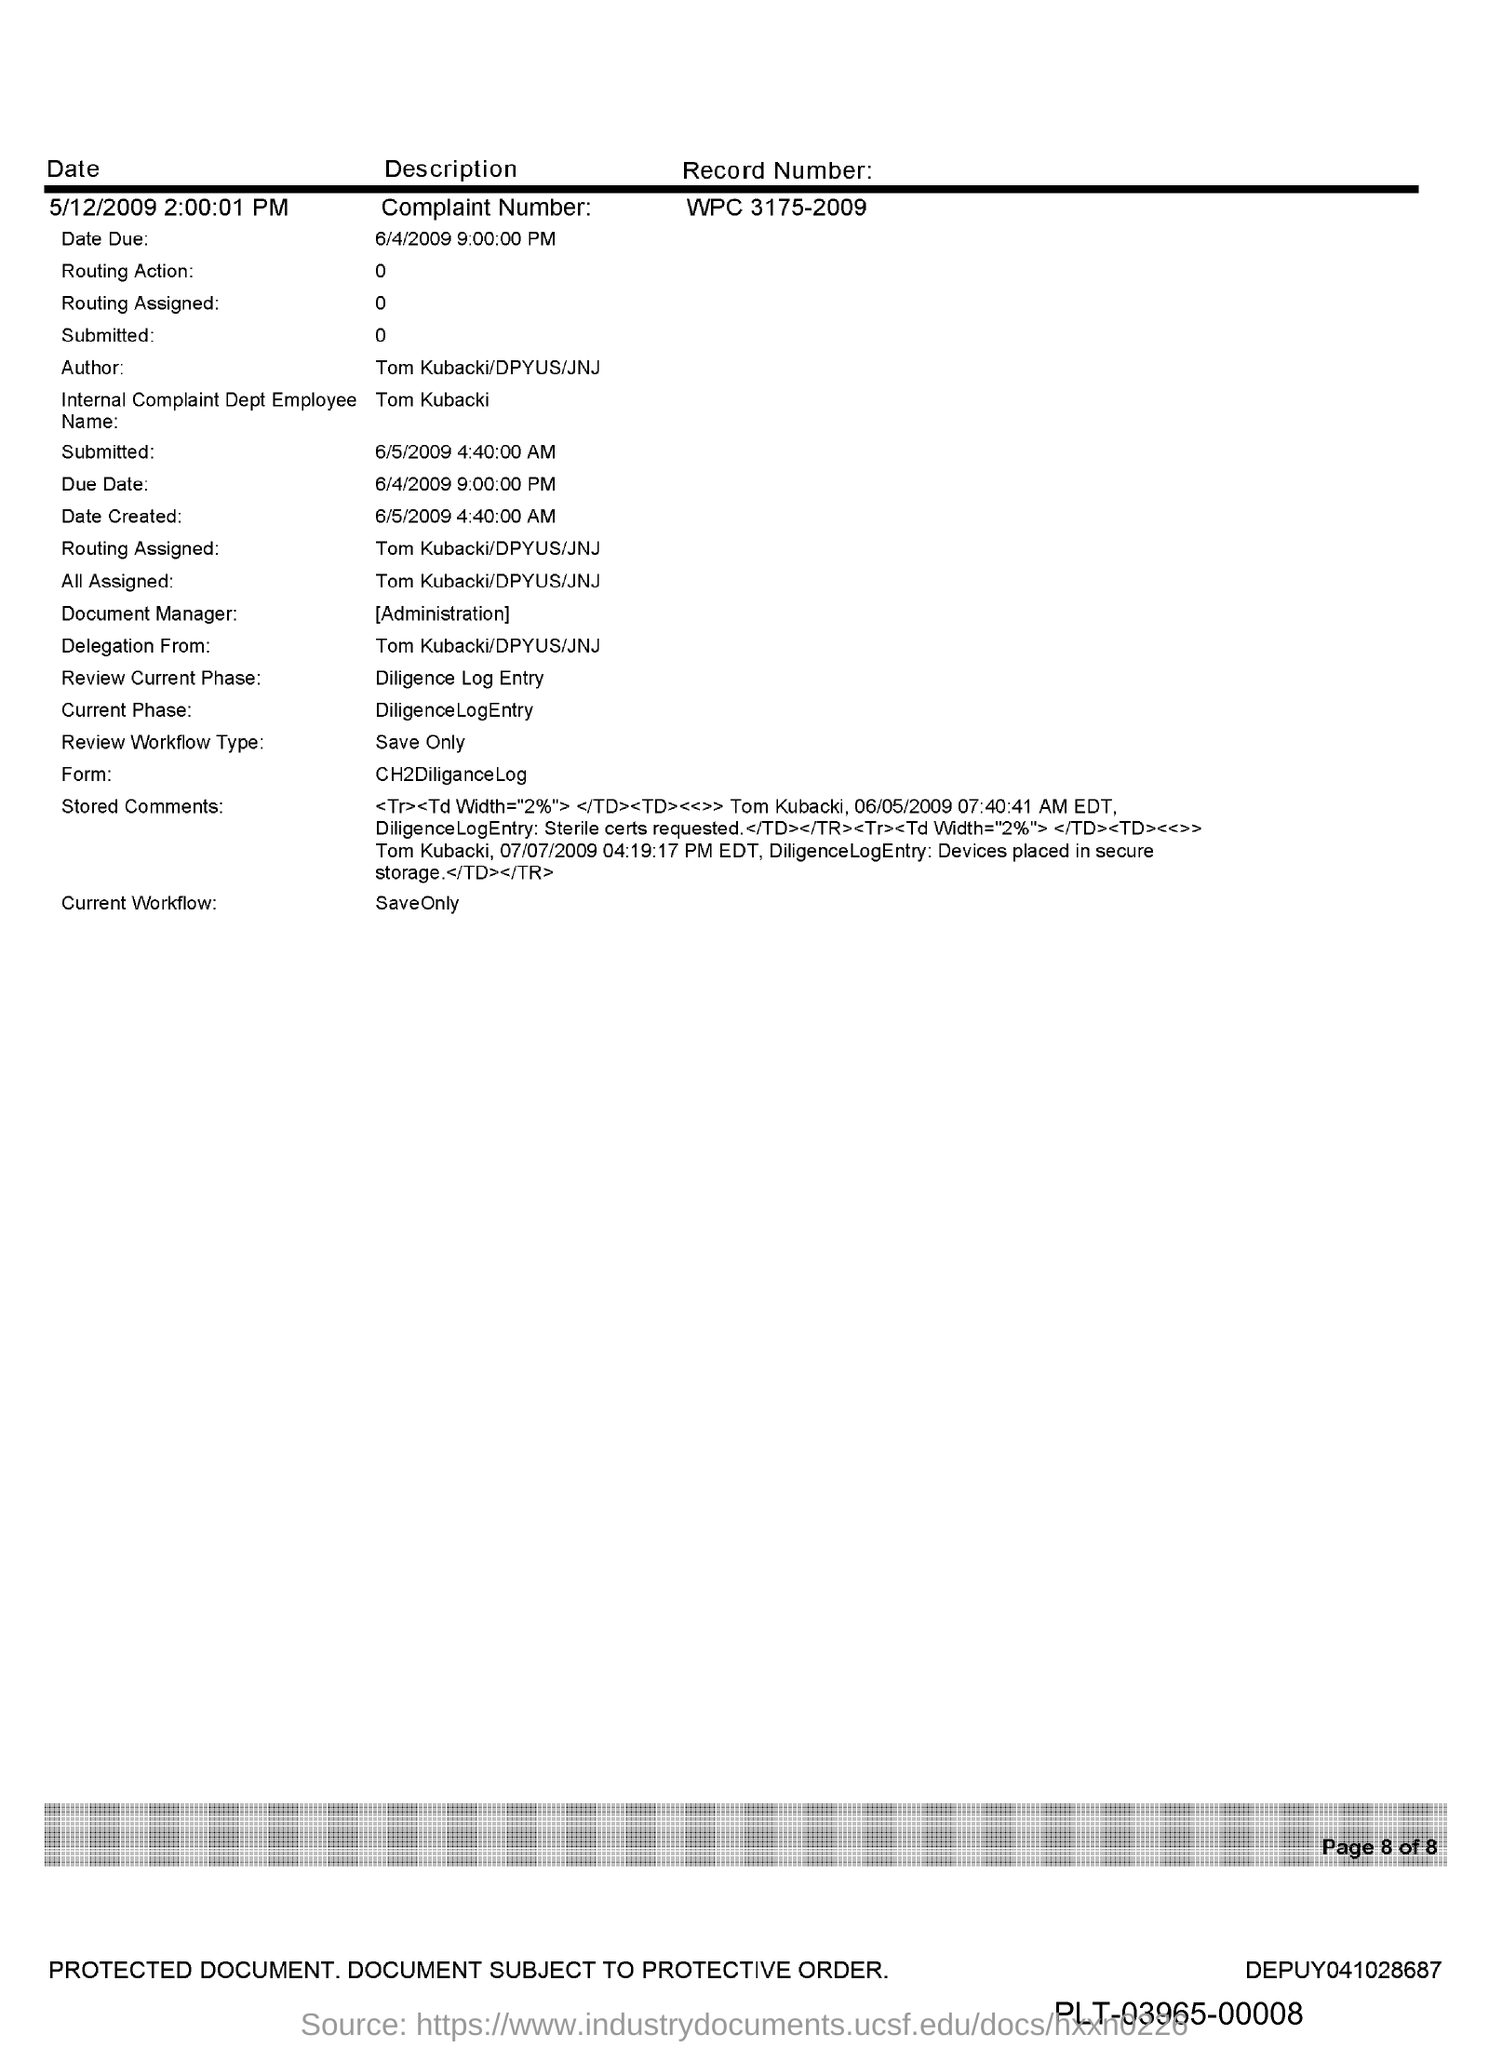Outline some significant characteristics in this image. The complaint number mentioned in the document is WPC 3175-2009. The document mentions an employee named Tom Kubacki in the Internal Complaint Department. The submitted date and time mentioned in the document is 6/5/2009 4:40:00 AM. 